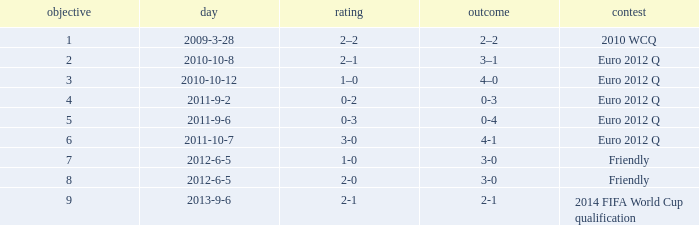How many goals when the score is 3-0 in the euro 2012 q? 1.0. 